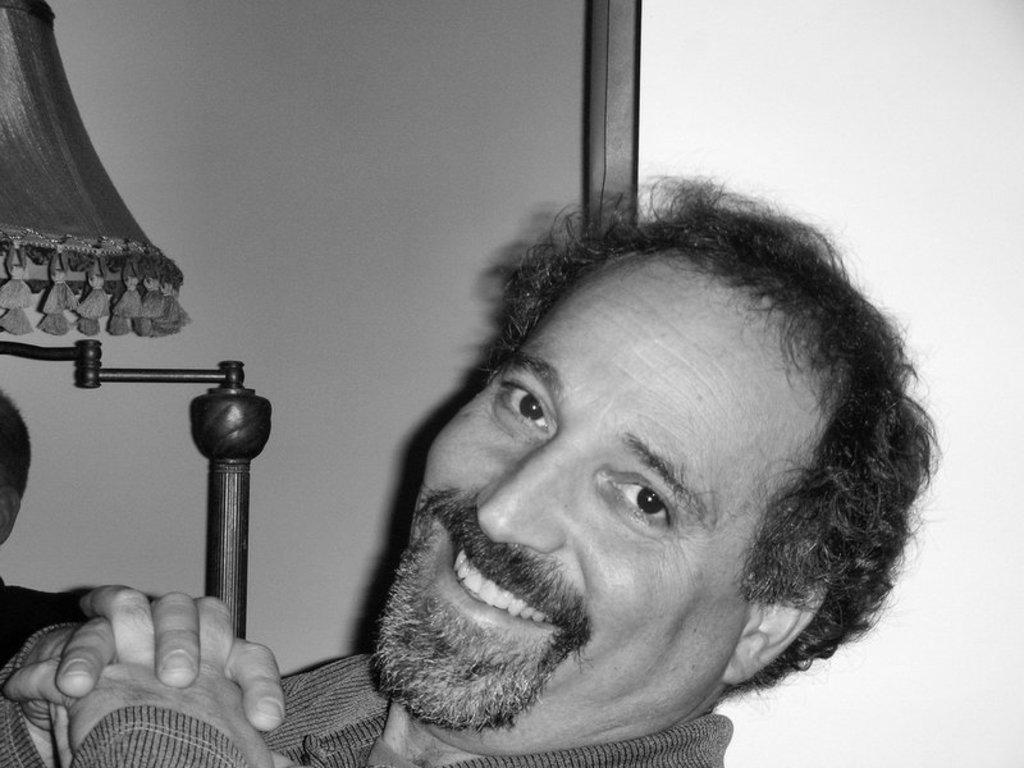Who is present in the image? There is a man in the image. What is the man doing in the image? The man is smiling in the image. What is the color scheme of the image? The image is black and white. What object can be seen on the left side of the image? There is a lamp on the left side of the image. What type of coal is being used to fuel the skate in the image? There is no coal or skate present in the image. What property does the man own in the image? The image does not provide information about the man's property ownership. 